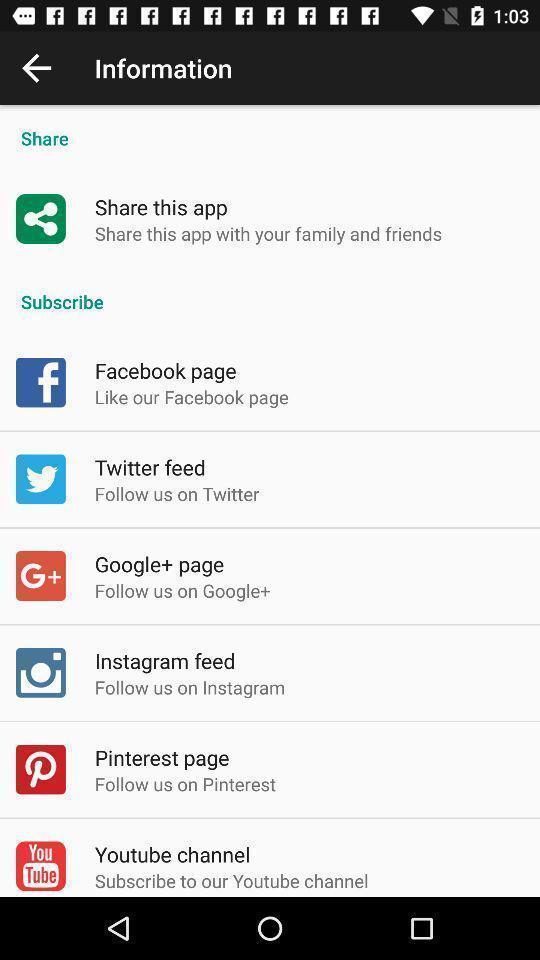Tell me what you see in this picture. Page showing information on a sound app. 